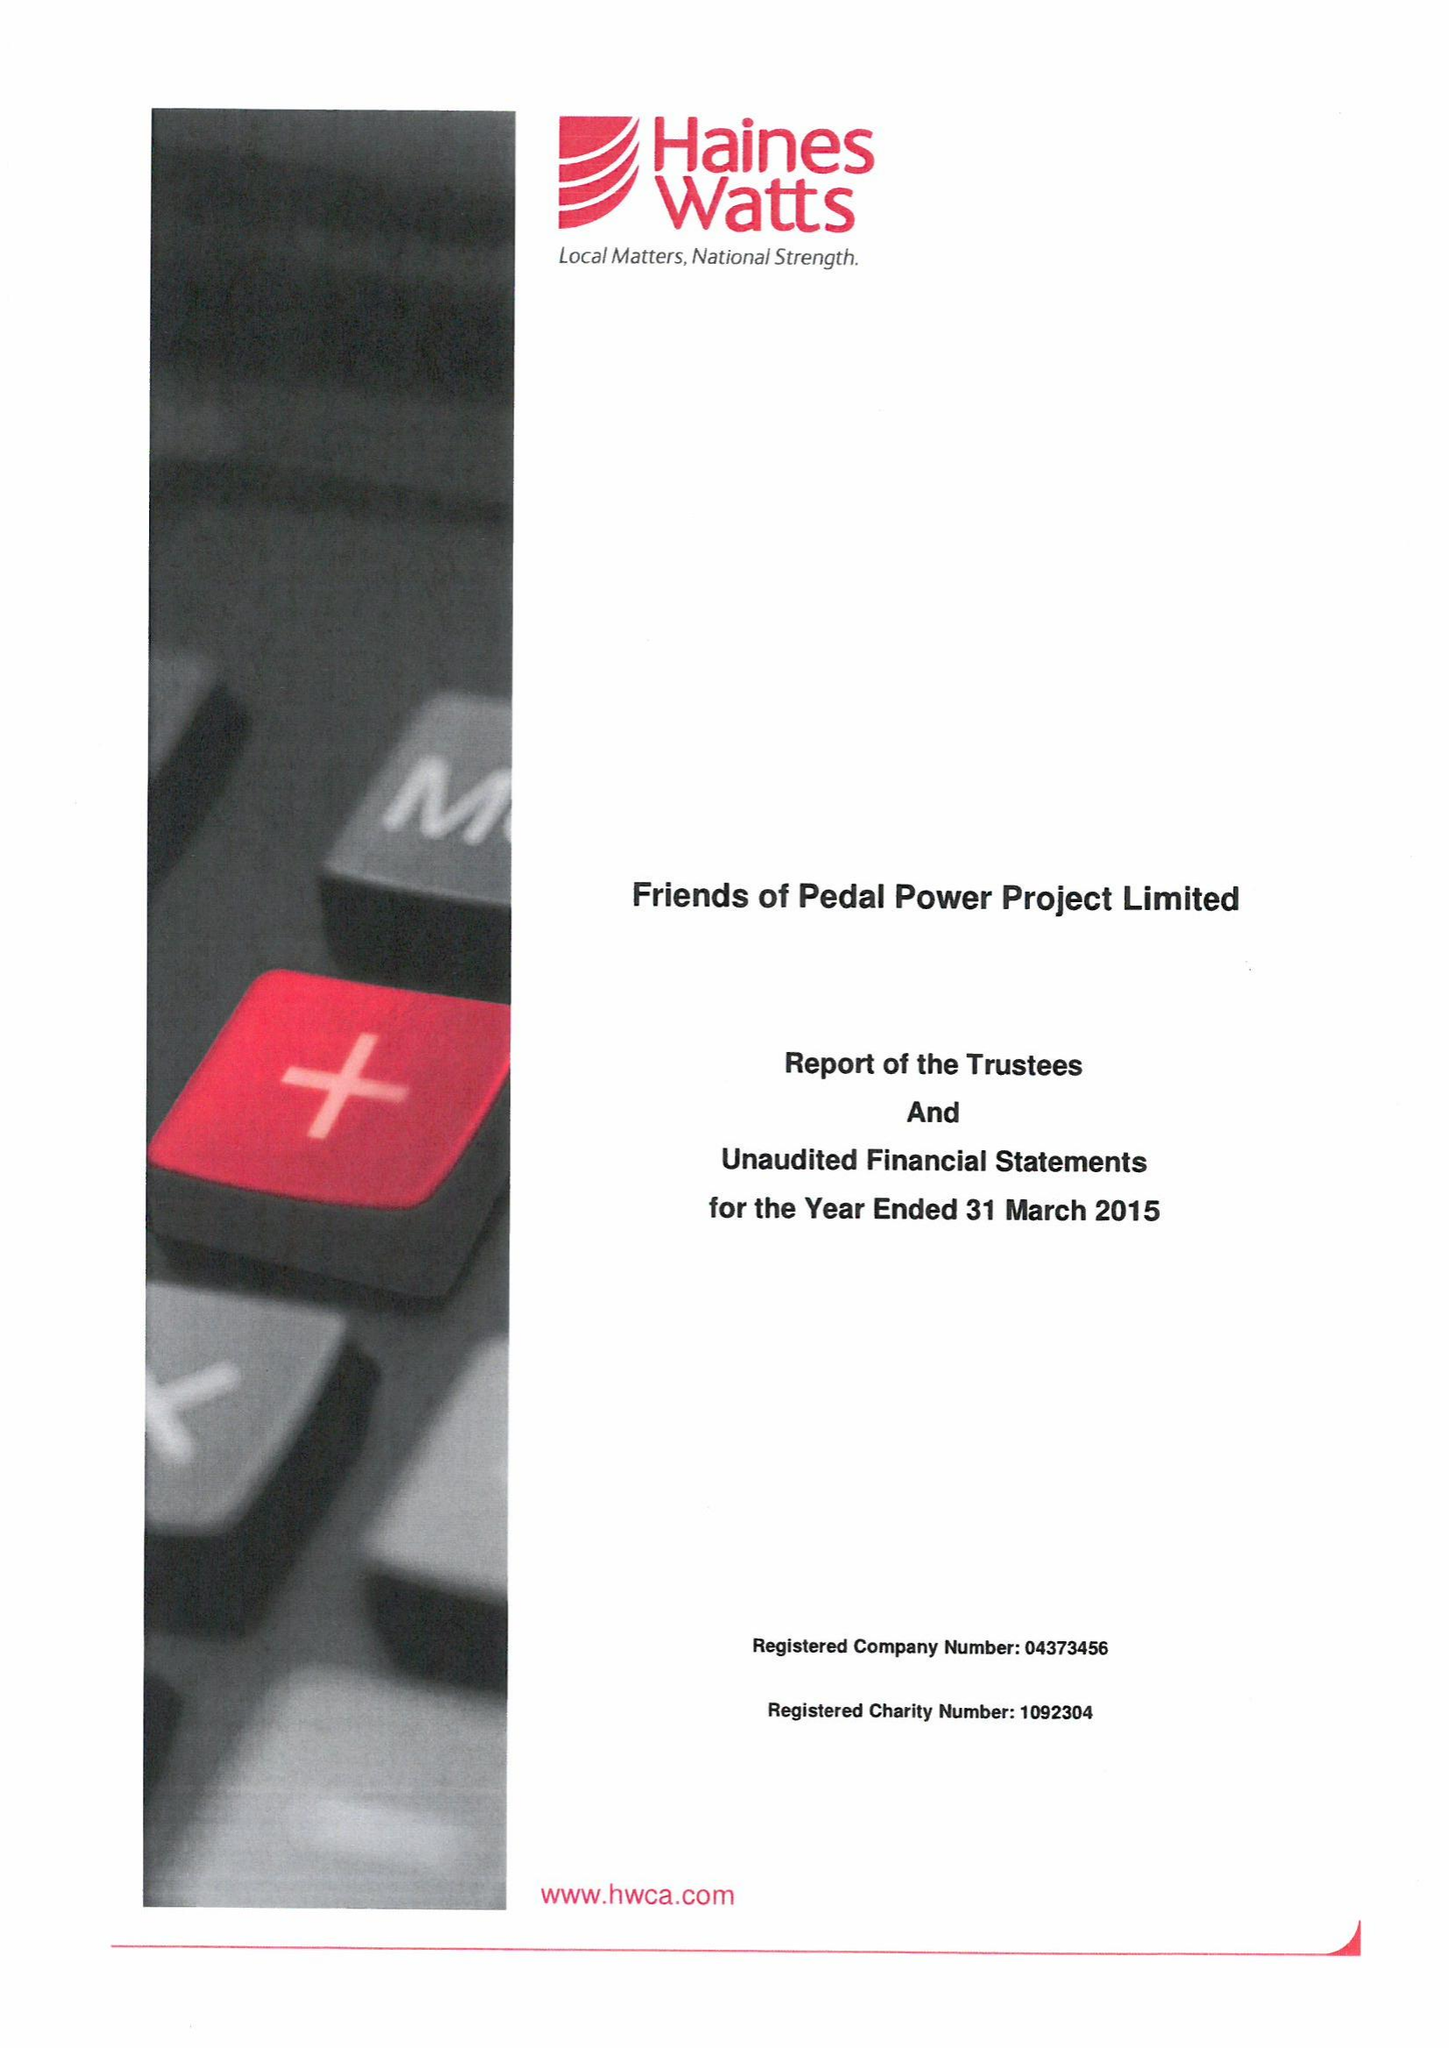What is the value for the spending_annually_in_british_pounds?
Answer the question using a single word or phrase. 348786.00 